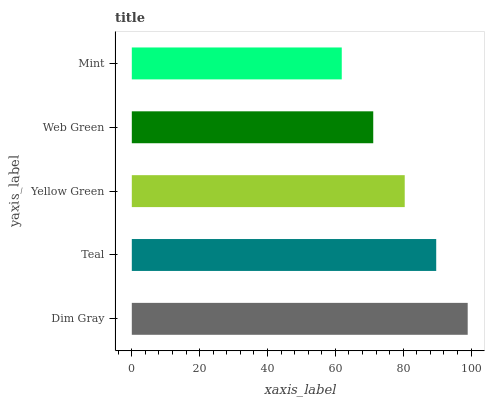Is Mint the minimum?
Answer yes or no. Yes. Is Dim Gray the maximum?
Answer yes or no. Yes. Is Teal the minimum?
Answer yes or no. No. Is Teal the maximum?
Answer yes or no. No. Is Dim Gray greater than Teal?
Answer yes or no. Yes. Is Teal less than Dim Gray?
Answer yes or no. Yes. Is Teal greater than Dim Gray?
Answer yes or no. No. Is Dim Gray less than Teal?
Answer yes or no. No. Is Yellow Green the high median?
Answer yes or no. Yes. Is Yellow Green the low median?
Answer yes or no. Yes. Is Teal the high median?
Answer yes or no. No. Is Dim Gray the low median?
Answer yes or no. No. 